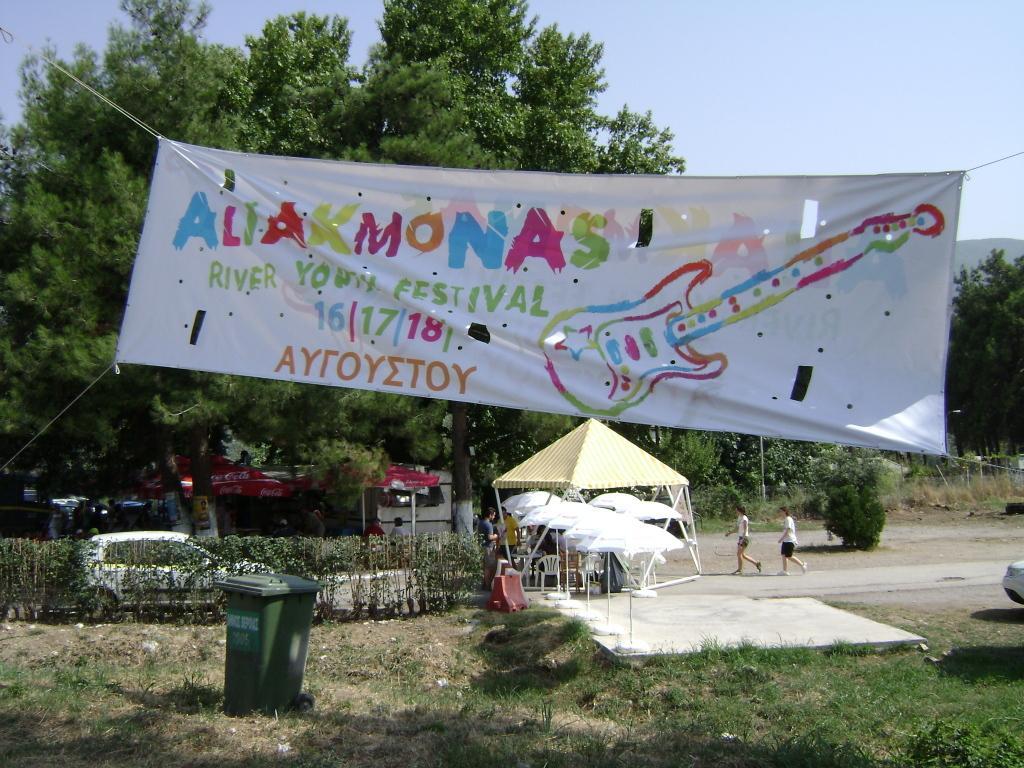How would you summarize this image in a sentence or two? This picture is clicked outside. In the foreground we can see the green grass, plants, text, numbers and the depiction of a guitar on the banner and we can see a dustbin, a car seems to be parked on the ground and we can see the tents, umbrellas, group of people and we can see the chairs and a white color object placed on the ground. In the background we can see the sky, trees, plants and some other objects. 